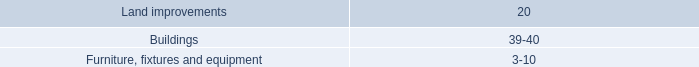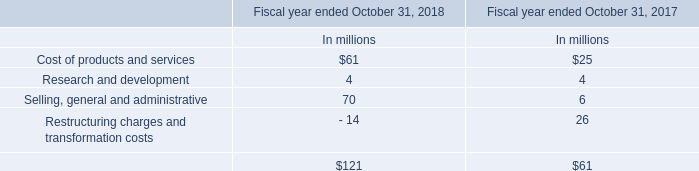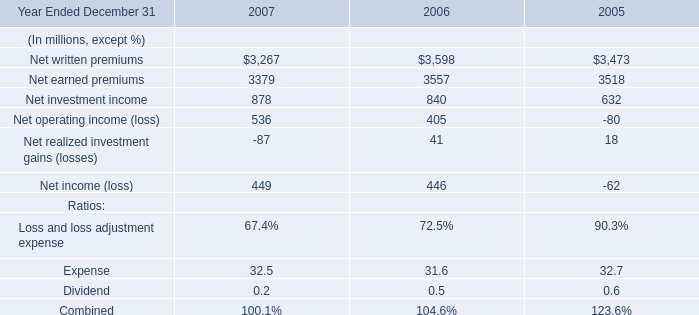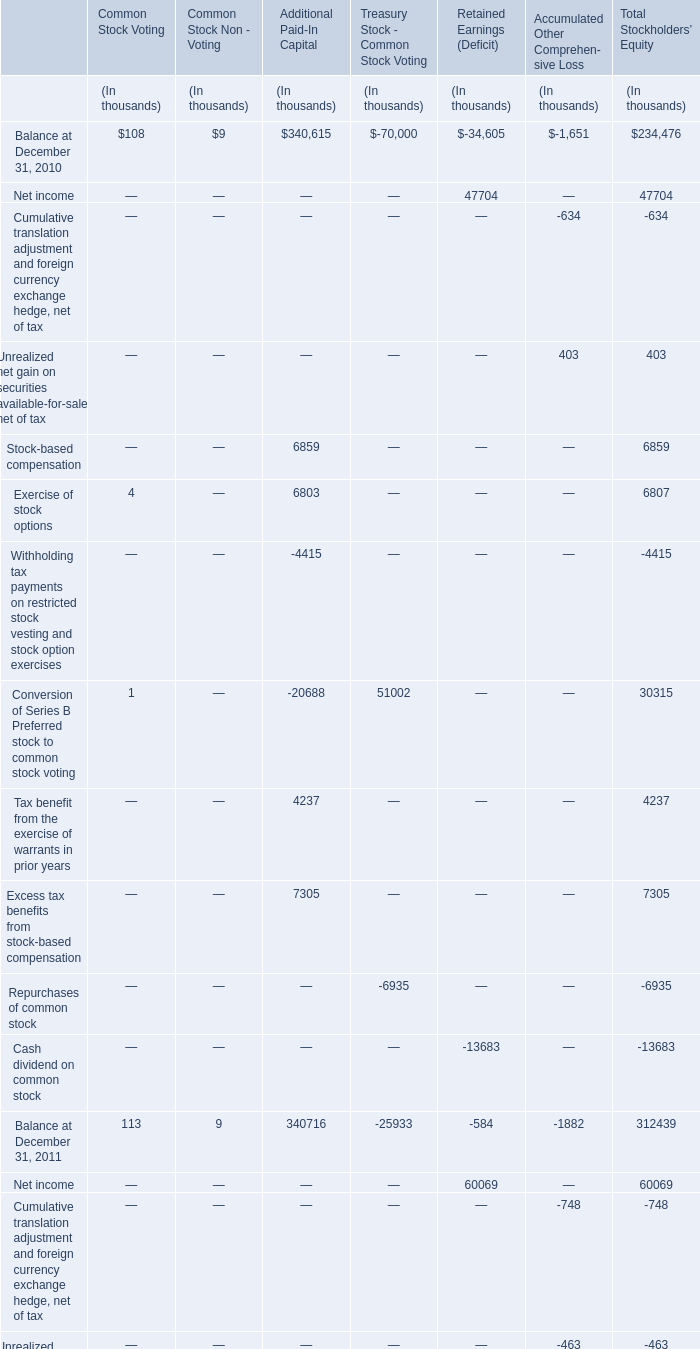What's the sum of all Common Stock Voting that are positive in 2010? (in thousand) 
Computations: ((108 + 4) + 1)
Answer: 113.0. 